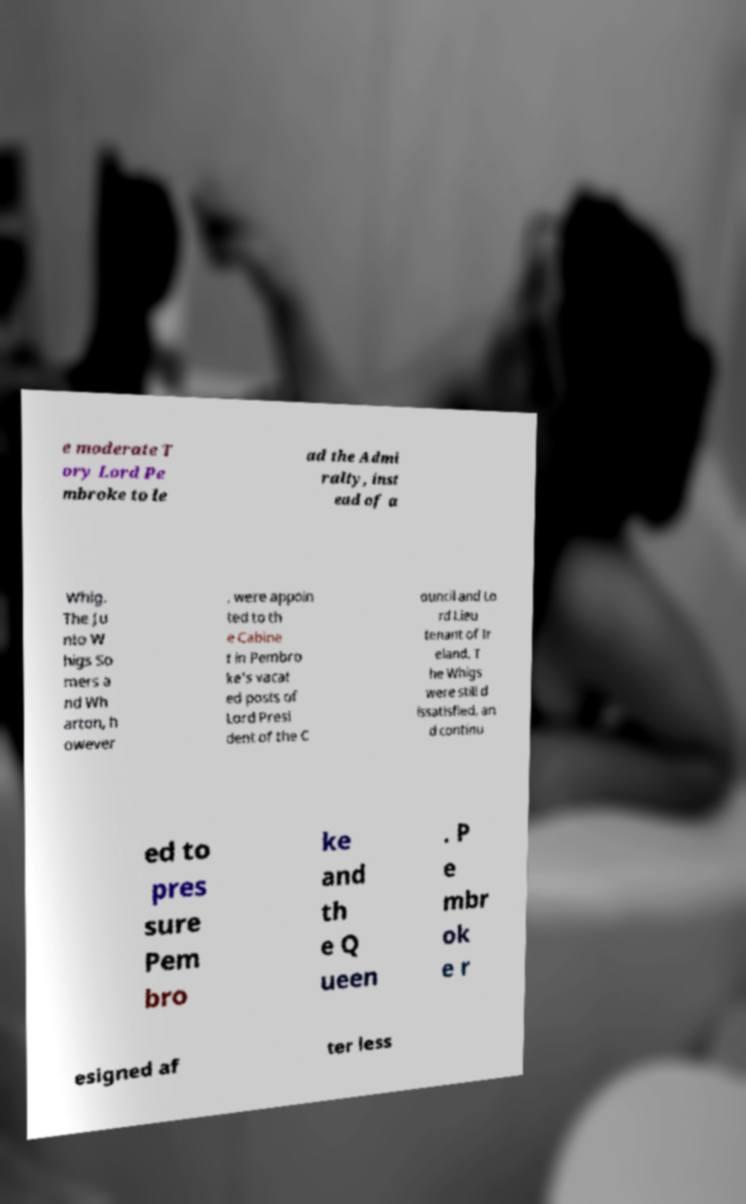Please identify and transcribe the text found in this image. e moderate T ory Lord Pe mbroke to le ad the Admi ralty, inst ead of a Whig. The Ju nto W higs So mers a nd Wh arton, h owever , were appoin ted to th e Cabine t in Pembro ke's vacat ed posts of Lord Presi dent of the C ouncil and Lo rd Lieu tenant of Ir eland. T he Whigs were still d issatisfied, an d continu ed to pres sure Pem bro ke and th e Q ueen . P e mbr ok e r esigned af ter less 